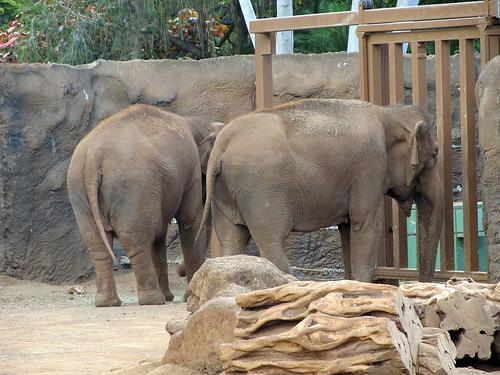Identify the two main objects in the elephant cage. Elephant facing fence and second elephant in cage. Describe two prominent elements found in the enclosure where the elephants are. Fake logs and large rock are present in the elephant cage. 